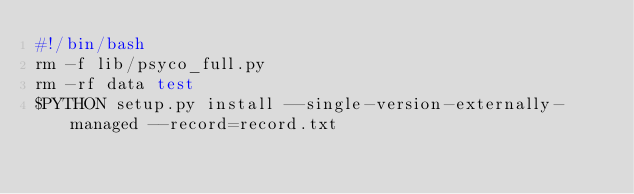Convert code to text. <code><loc_0><loc_0><loc_500><loc_500><_Bash_>#!/bin/bash
rm -f lib/psyco_full.py
rm -rf data test
$PYTHON setup.py install --single-version-externally-managed --record=record.txt
</code> 